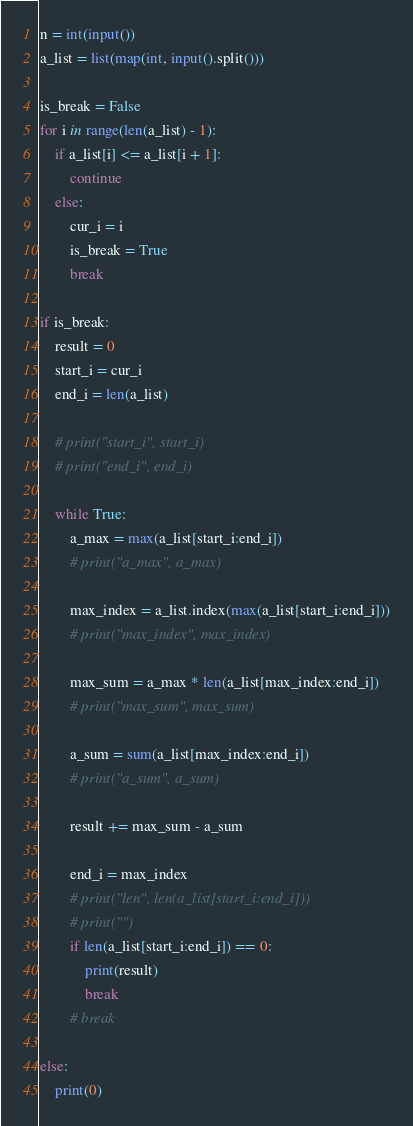<code> <loc_0><loc_0><loc_500><loc_500><_Python_>n = int(input())
a_list = list(map(int, input().split()))

is_break = False
for i in range(len(a_list) - 1):
    if a_list[i] <= a_list[i + 1]:
        continue
    else:
        cur_i = i
        is_break = True
        break

if is_break:
    result = 0
    start_i = cur_i
    end_i = len(a_list)

    # print("start_i", start_i)
    # print("end_i", end_i)

    while True:
        a_max = max(a_list[start_i:end_i])
        # print("a_max", a_max)

        max_index = a_list.index(max(a_list[start_i:end_i]))
        # print("max_index", max_index)

        max_sum = a_max * len(a_list[max_index:end_i])
        # print("max_sum", max_sum)

        a_sum = sum(a_list[max_index:end_i])
        # print("a_sum", a_sum)

        result += max_sum - a_sum

        end_i = max_index
        # print("len", len(a_list[start_i:end_i]))
        # print("")
        if len(a_list[start_i:end_i]) == 0:
            print(result)
            break
        # break

else:
    print(0)
</code> 